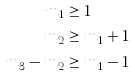Convert formula to latex. <formula><loc_0><loc_0><loc_500><loc_500>m _ { 1 } & \geq 1 \\ m _ { 2 } & \geq m _ { 1 } + 1 \\ m _ { 3 } - m _ { 2 } & \geq m _ { 1 } - 1 \\</formula> 